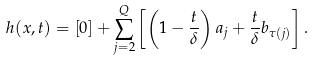<formula> <loc_0><loc_0><loc_500><loc_500>h ( x , t ) = [ 0 ] + \sum _ { j = 2 } ^ { Q } \left [ \left ( 1 - \frac { t } { \delta } \right ) a _ { j } + \frac { t } { \delta } b _ { \tau ( j ) } \right ] .</formula> 